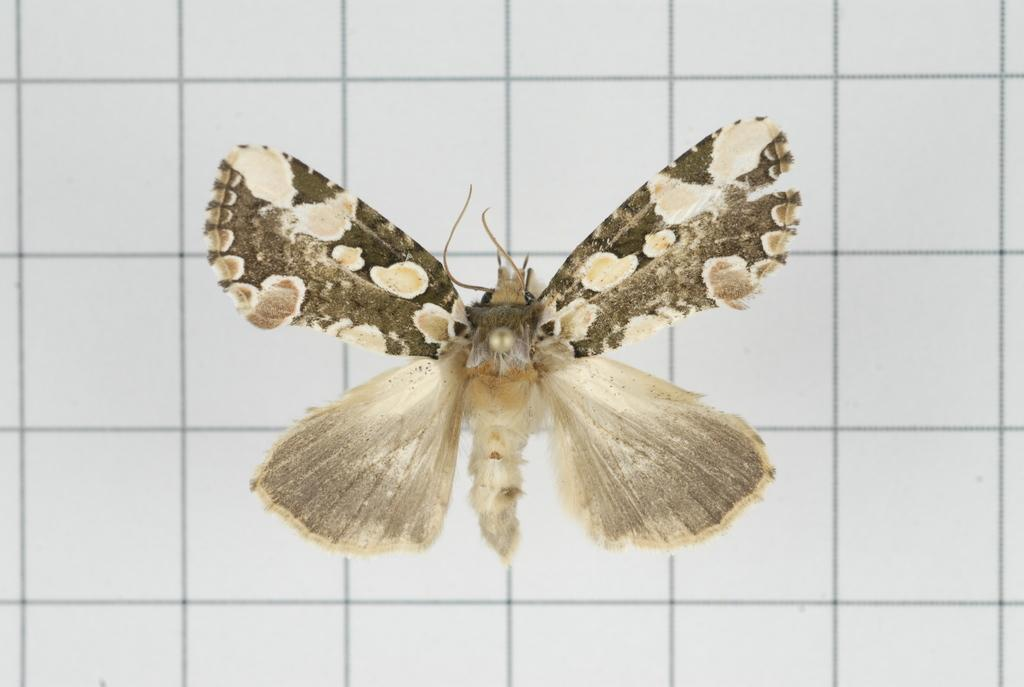What type of creature is present in the image? There is a butterfly in the image. Can you describe the color of the butterfly? The butterfly is white and ash colored. How many apples are hanging from the bulb in the image? There are no apples or bulbs present in the image; it features a butterfly. What type of seed can be seen growing near the butterfly in the image? There is no seed present in the image; it only features a butterfly. 